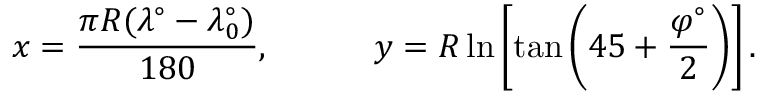<formula> <loc_0><loc_0><loc_500><loc_500>x = { \frac { \pi R ( \lambda ^ { \circ } - \lambda _ { 0 } ^ { \circ } ) } { 1 8 0 } } , \quad y = R \ln \left [ \tan \left ( 4 5 + { \frac { \varphi ^ { \circ } } { 2 } } \right ) \right ] .</formula> 